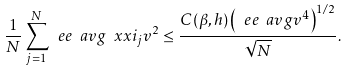<formula> <loc_0><loc_0><loc_500><loc_500>\frac { 1 } { N } \sum _ { j = 1 } ^ { N } \ e e \ a v g { \ x x i _ { j } v } ^ { 2 } \leq \frac { C ( \beta , h ) \left ( \ e e \ a v g { v ^ { 4 } } \right ) ^ { 1 / 2 } } { \sqrt { N } } .</formula> 